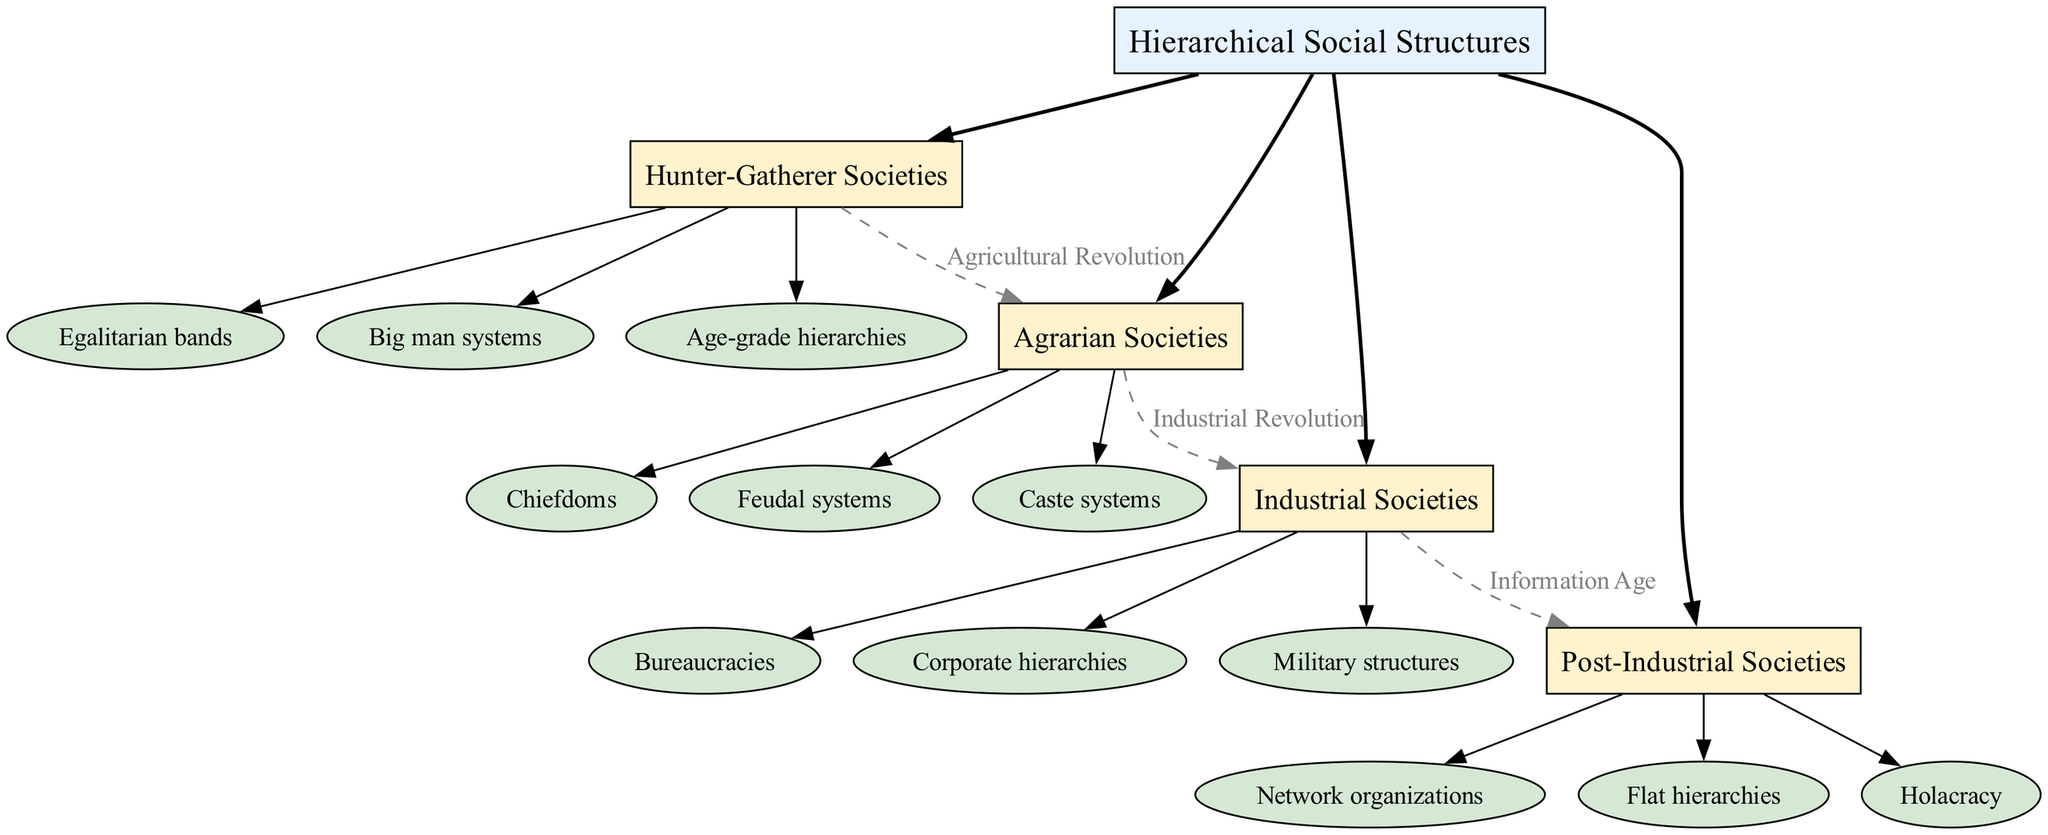What is the root of the diagram? The diagram shows "Hierarchical Social Structures" as the root node, positioned at the top of the structure.
Answer: Hierarchical Social Structures How many branches does the diagram have? The diagram includes four branches, which are Hunter-Gatherer Societies, Agrarian Societies, Industrial Societies, and Post-Industrial Societies.
Answer: 4 What label connects Hunter-Gatherer Societies to Agrarian Societies? The label that connects these two branches is "Agricultural Revolution," indicating a significant transition between these societal types.
Answer: Agricultural Revolution What is one type of social structure within Industrial Societies? One of the nodes under Industrial Societies is "Bureaucracies," representing a form of hierarchical organization prevalent in such societies.
Answer: Bureaucracies Which branch is connected by a dashed line to Industrial Societies? The branch connected to Industrial Societies by a dashed line is "Post-Industrial Societies," indicating a progression in social structure.
Answer: Post-Industrial Societies How many nodes are listed under Agrarian Societies? There are three nodes depicted under Agrarian Societies, which are Chiefdoms, Feudal systems, and Caste systems.
Answer: 3 What is the last labeled connection in the diagram? The last labeled connection is "Information Age," linking Industrial Societies to Post-Industrial Societies and signifying a transformative era.
Answer: Information Age What type of hierarchy is found in Hunter-Gatherer Societies? The type of hierarchy found is "Egalitarian bands," indicating a flattened structure with minimal hierarchy.
Answer: Egalitarian bands Which societies exhibit "Flat hierarchies"? "Flat hierarchies" is a characteristic of Post-Industrial Societies, showcasing an evolution towards less hierarchical structures.
Answer: Post-Industrial Societies Name a social structure from Agrarian Societies that reflects a closed class system. "Caste systems" are representative of a closed class system, typically associated with Agrarian Societies where social mobility is restricted.
Answer: Caste systems 